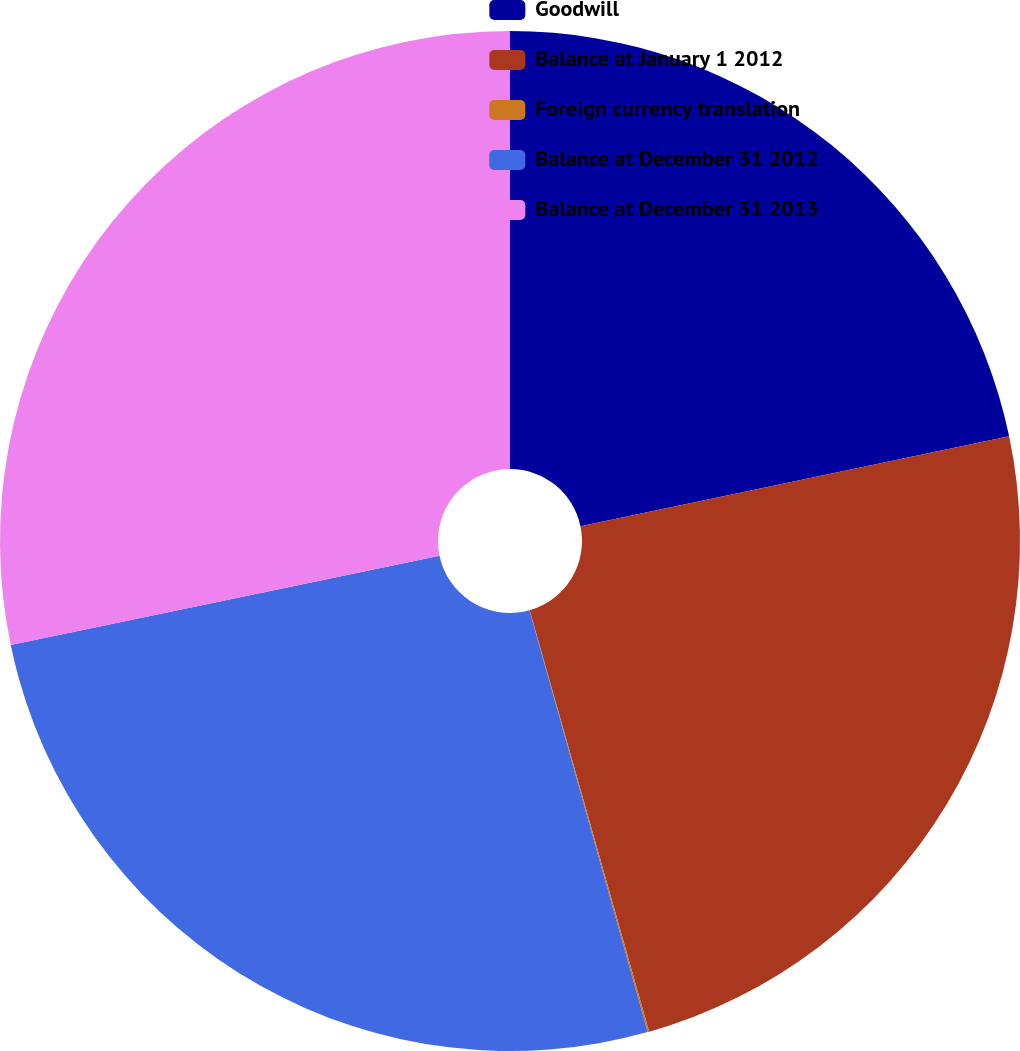Convert chart to OTSL. <chart><loc_0><loc_0><loc_500><loc_500><pie_chart><fcel>Goodwill<fcel>Balance at January 1 2012<fcel>Foreign currency translation<fcel>Balance at December 31 2012<fcel>Balance at December 31 2013<nl><fcel>21.71%<fcel>23.89%<fcel>0.05%<fcel>26.08%<fcel>28.27%<nl></chart> 